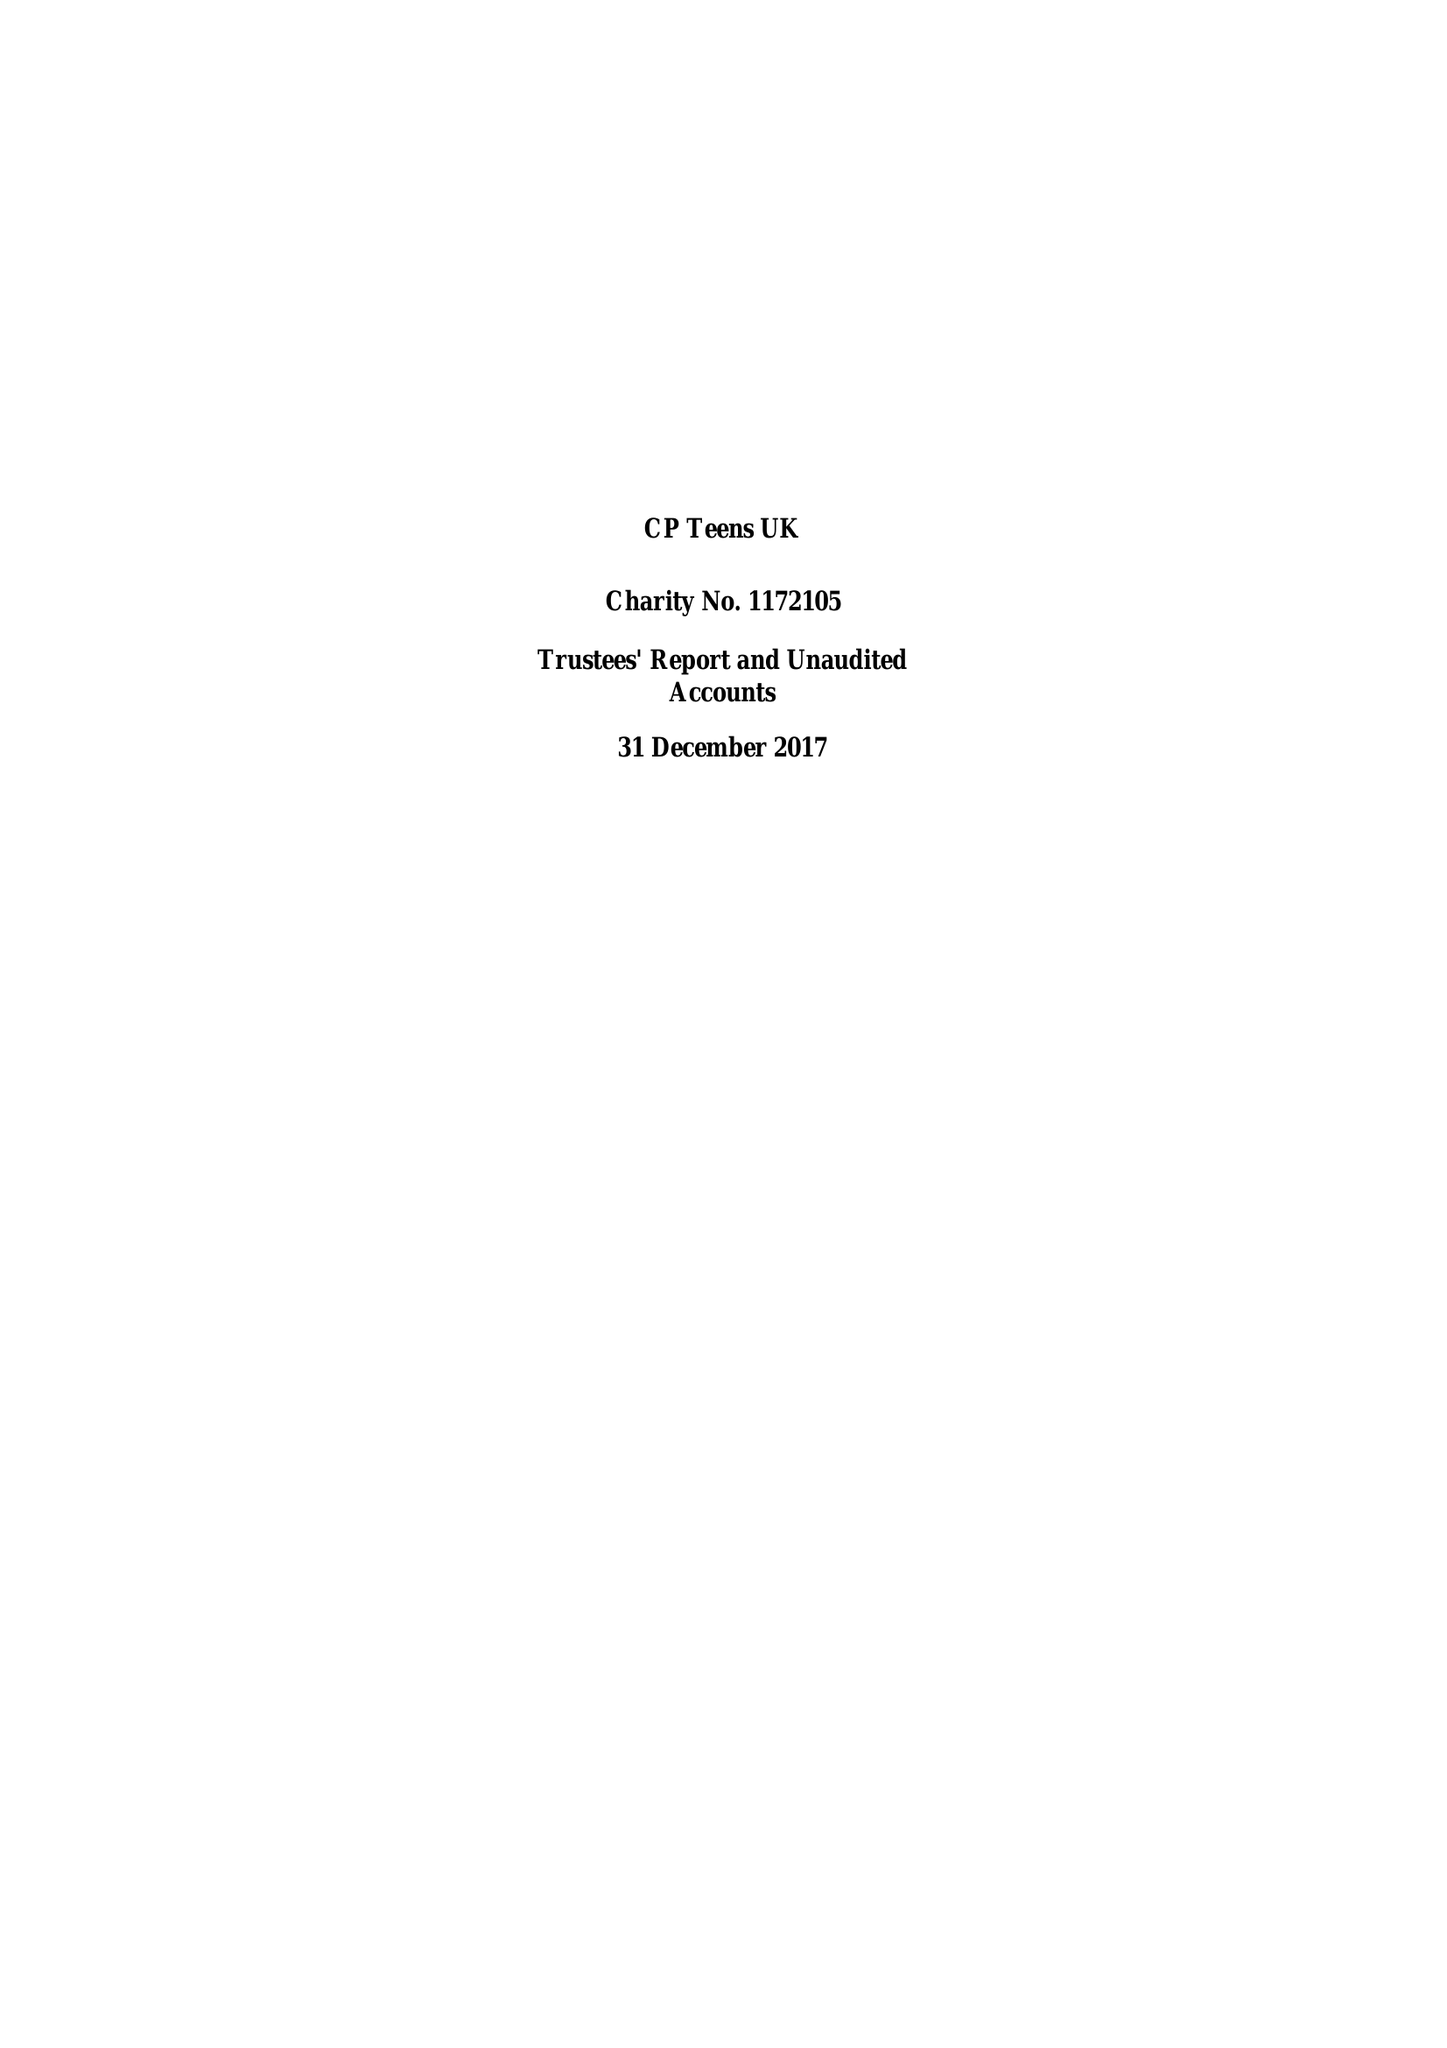What is the value for the address__post_town?
Answer the question using a single word or phrase. CHESTERFIELD 